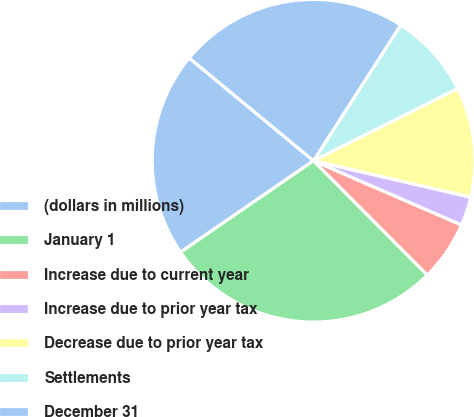Convert chart. <chart><loc_0><loc_0><loc_500><loc_500><pie_chart><fcel>(dollars in millions)<fcel>January 1<fcel>Increase due to current year<fcel>Increase due to prior year tax<fcel>Decrease due to prior year tax<fcel>Settlements<fcel>December 31<nl><fcel>20.59%<fcel>27.88%<fcel>6.02%<fcel>2.89%<fcel>11.02%<fcel>8.52%<fcel>23.09%<nl></chart> 